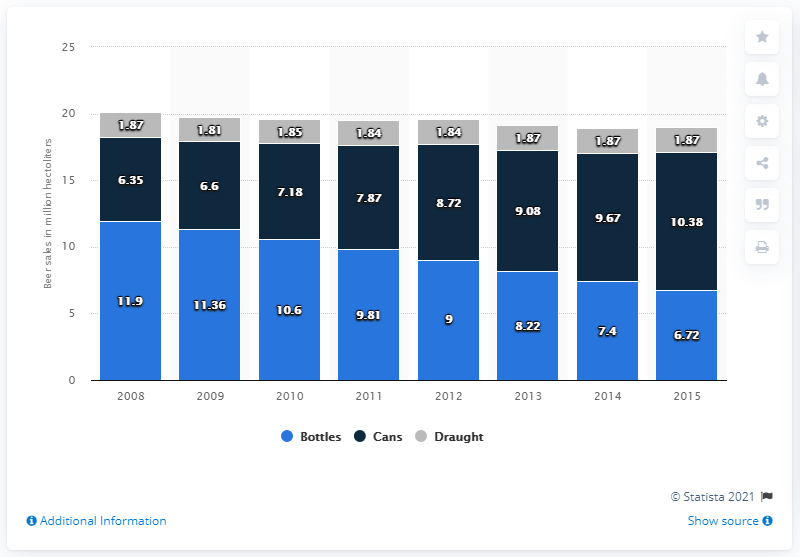List a handful of essential elements in this visual. In the year 2010, the total amount of all types of Canadian brand beer sold in Canada was 19.63 million hectoliters. In the year 2010, Canadian brand beer was sold in Canada in the amount of 10.6 million hectoliters. In 2013, Canada sold approximately 9.08 hectoliters of canned Canadian branded beer. 